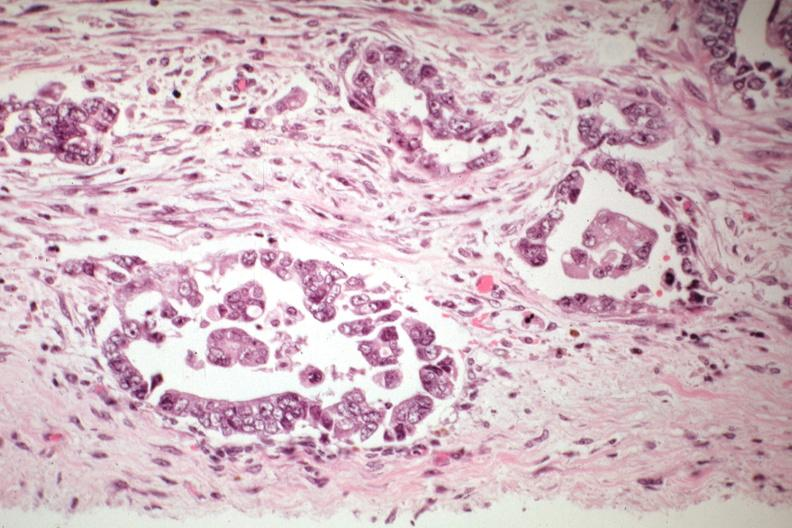s uterus present?
Answer the question using a single word or phrase. Yes 